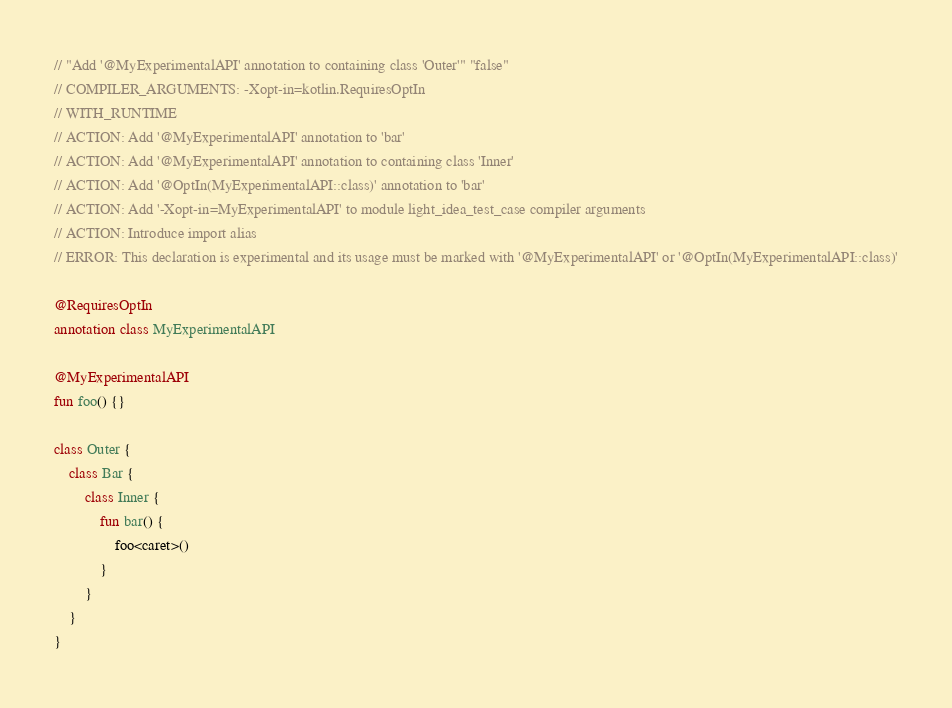Convert code to text. <code><loc_0><loc_0><loc_500><loc_500><_Kotlin_>// "Add '@MyExperimentalAPI' annotation to containing class 'Outer'" "false"
// COMPILER_ARGUMENTS: -Xopt-in=kotlin.RequiresOptIn
// WITH_RUNTIME
// ACTION: Add '@MyExperimentalAPI' annotation to 'bar'
// ACTION: Add '@MyExperimentalAPI' annotation to containing class 'Inner'
// ACTION: Add '@OptIn(MyExperimentalAPI::class)' annotation to 'bar'
// ACTION: Add '-Xopt-in=MyExperimentalAPI' to module light_idea_test_case compiler arguments
// ACTION: Introduce import alias
// ERROR: This declaration is experimental and its usage must be marked with '@MyExperimentalAPI' or '@OptIn(MyExperimentalAPI::class)'

@RequiresOptIn
annotation class MyExperimentalAPI

@MyExperimentalAPI
fun foo() {}

class Outer {
    class Bar {
        class Inner {
            fun bar() {
                foo<caret>()
            }
        }
    }
}
</code> 